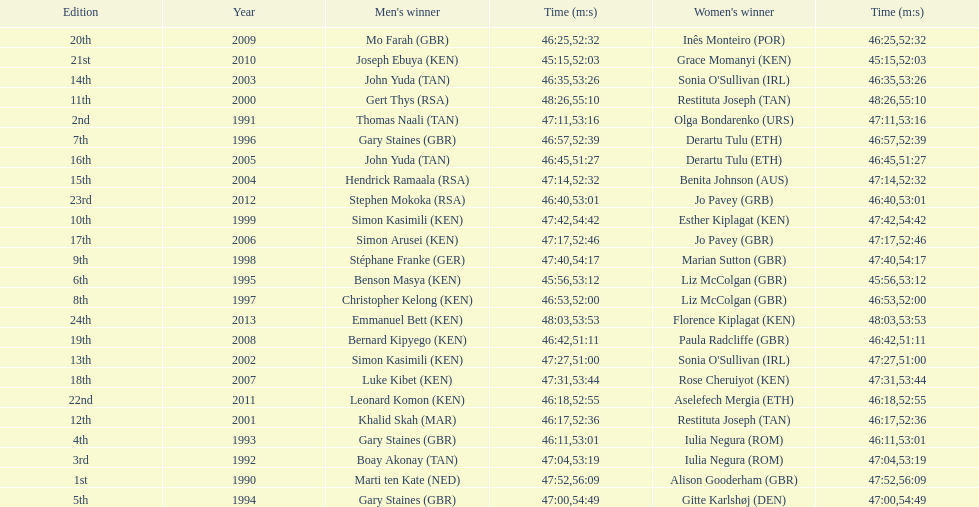How long did sonia o'sullivan take to finish in 2003? 53:26. 